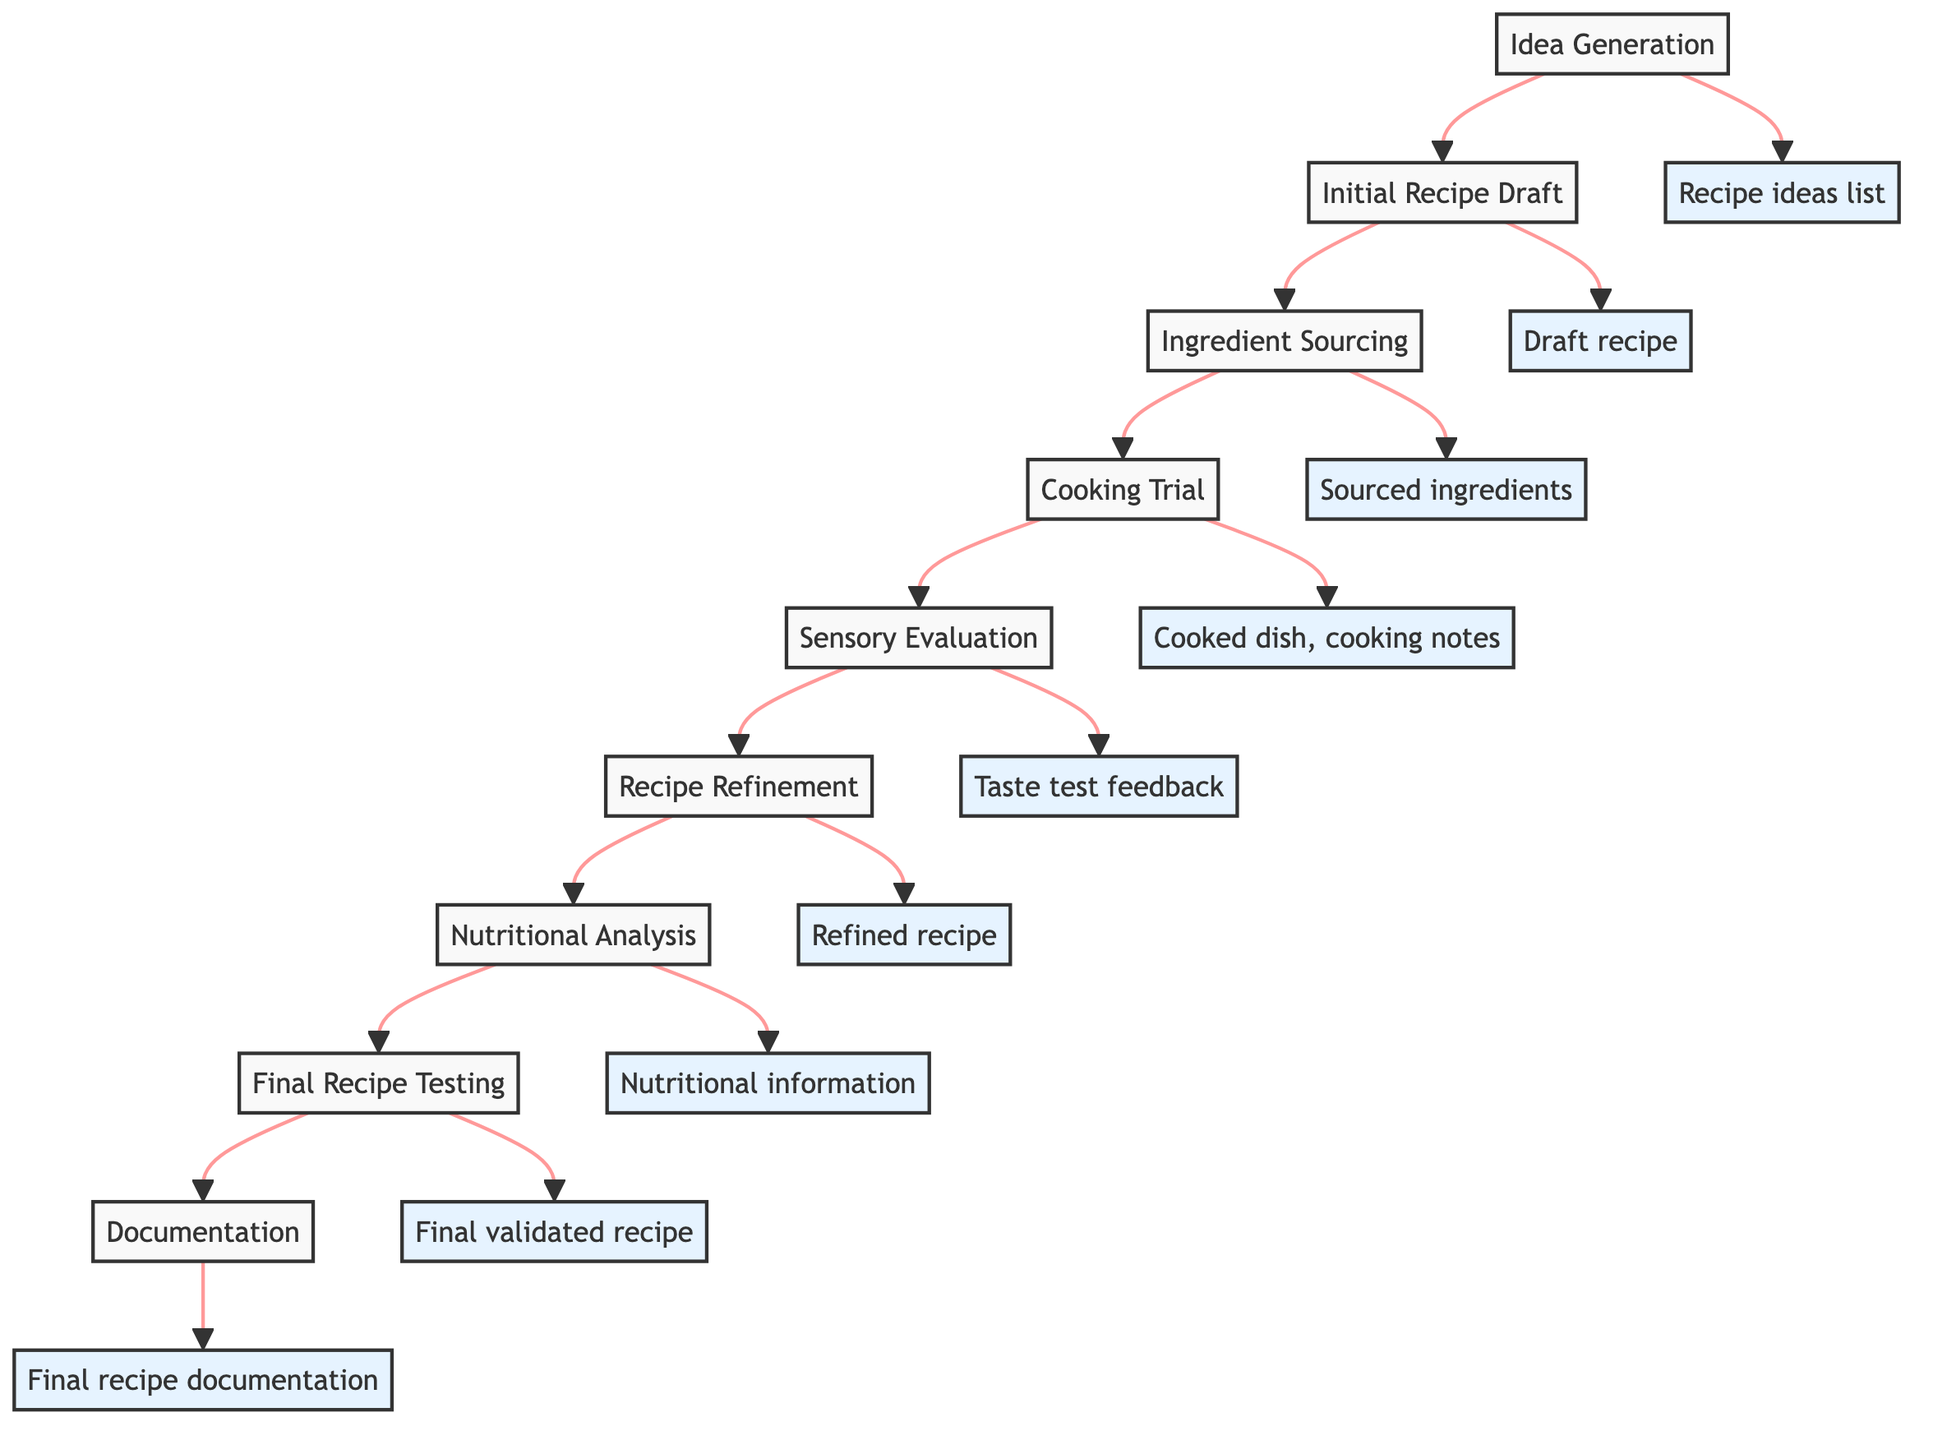What is the first step in the Cook and Test Process? The first step listed in the flow chart is "Idea Generation," which initiates the entire process.
Answer: Idea Generation How many total steps are there in the process? By counting each step in the flow chart, we find there are a total of nine steps from "Idea Generation" to "Documentation."
Answer: Nine What is the output of the 'Cooking Trial' step? According to the flow chart, the output of the 'Cooking Trial' step is "Cooked dish, cooking notes."
Answer: Cooked dish, cooking notes Which step follows 'Sensory Evaluation'? The step that follows 'Sensory Evaluation' is 'Recipe Refinement,' indicating that adjustments are made after feedback is received.
Answer: Recipe Refinement What is the relationship between 'Ingredient Sourcing' and 'Cooking Trial'? 'Ingredient Sourcing' is a prerequisite to 'Cooking Trial,' meaning ingredients must be gathered before the cooking can begin.
Answer: Prerequisite What type of evaluation is conducted after cooking the dish? A 'Sensory Evaluation' is conducted after the cooking trial to gather feedback on the dish's flavor and texture.
Answer: Sensory Evaluation Which step concerns nutritional content analysis? The step dedicated to understanding nutritional content is 'Nutritional Analysis.' This is performed to meet dietary guidelines.
Answer: Nutritional Analysis What is the final output of the entire process? The final output of the process is 'Final recipe documentation,' which includes detailed instructions and tips for the publication.
Answer: Final recipe documentation How does 'Recipe Refinement' influence the subsequent steps? 'Recipe Refinement' impacts the next step, 'Nutritional Analysis,' as changes made to the recipe can affect its nutritional content.
Answer: Impacts nutritional analysis 